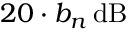Convert formula to latex. <formula><loc_0><loc_0><loc_500><loc_500>2 0 \cdot b _ { n } \, d B</formula> 